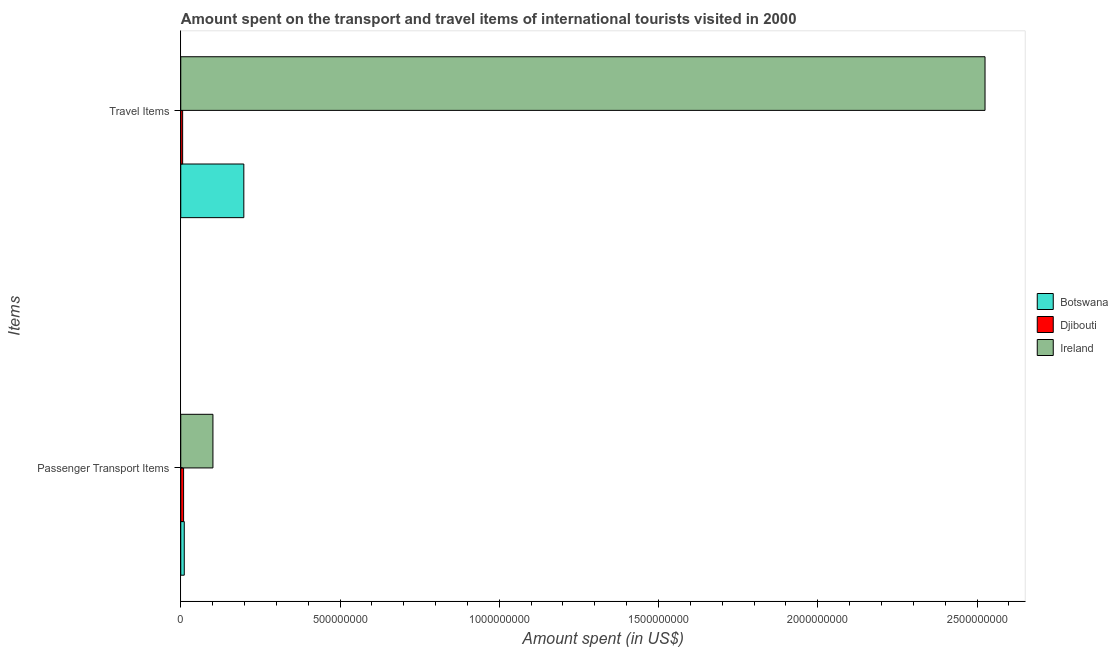How many different coloured bars are there?
Provide a short and direct response. 3. How many groups of bars are there?
Provide a short and direct response. 2. Are the number of bars per tick equal to the number of legend labels?
Your answer should be compact. Yes. Are the number of bars on each tick of the Y-axis equal?
Offer a terse response. Yes. What is the label of the 2nd group of bars from the top?
Your answer should be compact. Passenger Transport Items. What is the amount spent on passenger transport items in Botswana?
Give a very brief answer. 1.10e+07. Across all countries, what is the maximum amount spent in travel items?
Your answer should be very brief. 2.52e+09. Across all countries, what is the minimum amount spent on passenger transport items?
Offer a very short reply. 8.90e+06. In which country was the amount spent on passenger transport items maximum?
Keep it short and to the point. Ireland. In which country was the amount spent on passenger transport items minimum?
Your answer should be very brief. Djibouti. What is the total amount spent on passenger transport items in the graph?
Ensure brevity in your answer.  1.21e+08. What is the difference between the amount spent on passenger transport items in Ireland and that in Djibouti?
Ensure brevity in your answer.  9.21e+07. What is the difference between the amount spent in travel items in Djibouti and the amount spent on passenger transport items in Botswana?
Make the answer very short. -5.10e+06. What is the average amount spent in travel items per country?
Keep it short and to the point. 9.10e+08. What is the difference between the amount spent in travel items and amount spent on passenger transport items in Botswana?
Ensure brevity in your answer.  1.87e+08. What is the ratio of the amount spent in travel items in Djibouti to that in Botswana?
Your answer should be very brief. 0.03. What does the 2nd bar from the top in Passenger Transport Items represents?
Keep it short and to the point. Djibouti. What does the 2nd bar from the bottom in Passenger Transport Items represents?
Keep it short and to the point. Djibouti. Does the graph contain any zero values?
Ensure brevity in your answer.  No. How many legend labels are there?
Give a very brief answer. 3. How are the legend labels stacked?
Your response must be concise. Vertical. What is the title of the graph?
Your answer should be very brief. Amount spent on the transport and travel items of international tourists visited in 2000. What is the label or title of the X-axis?
Provide a short and direct response. Amount spent (in US$). What is the label or title of the Y-axis?
Provide a succinct answer. Items. What is the Amount spent (in US$) of Botswana in Passenger Transport Items?
Make the answer very short. 1.10e+07. What is the Amount spent (in US$) of Djibouti in Passenger Transport Items?
Give a very brief answer. 8.90e+06. What is the Amount spent (in US$) of Ireland in Passenger Transport Items?
Offer a terse response. 1.01e+08. What is the Amount spent (in US$) in Botswana in Travel Items?
Your answer should be compact. 1.98e+08. What is the Amount spent (in US$) in Djibouti in Travel Items?
Your response must be concise. 5.90e+06. What is the Amount spent (in US$) in Ireland in Travel Items?
Offer a terse response. 2.52e+09. Across all Items, what is the maximum Amount spent (in US$) in Botswana?
Ensure brevity in your answer.  1.98e+08. Across all Items, what is the maximum Amount spent (in US$) in Djibouti?
Make the answer very short. 8.90e+06. Across all Items, what is the maximum Amount spent (in US$) in Ireland?
Keep it short and to the point. 2.52e+09. Across all Items, what is the minimum Amount spent (in US$) in Botswana?
Offer a terse response. 1.10e+07. Across all Items, what is the minimum Amount spent (in US$) in Djibouti?
Provide a short and direct response. 5.90e+06. Across all Items, what is the minimum Amount spent (in US$) in Ireland?
Offer a terse response. 1.01e+08. What is the total Amount spent (in US$) in Botswana in the graph?
Ensure brevity in your answer.  2.09e+08. What is the total Amount spent (in US$) in Djibouti in the graph?
Offer a terse response. 1.48e+07. What is the total Amount spent (in US$) in Ireland in the graph?
Your answer should be very brief. 2.63e+09. What is the difference between the Amount spent (in US$) in Botswana in Passenger Transport Items and that in Travel Items?
Offer a very short reply. -1.87e+08. What is the difference between the Amount spent (in US$) of Djibouti in Passenger Transport Items and that in Travel Items?
Offer a terse response. 3.00e+06. What is the difference between the Amount spent (in US$) in Ireland in Passenger Transport Items and that in Travel Items?
Offer a very short reply. -2.42e+09. What is the difference between the Amount spent (in US$) of Botswana in Passenger Transport Items and the Amount spent (in US$) of Djibouti in Travel Items?
Ensure brevity in your answer.  5.10e+06. What is the difference between the Amount spent (in US$) of Botswana in Passenger Transport Items and the Amount spent (in US$) of Ireland in Travel Items?
Ensure brevity in your answer.  -2.51e+09. What is the difference between the Amount spent (in US$) of Djibouti in Passenger Transport Items and the Amount spent (in US$) of Ireland in Travel Items?
Provide a short and direct response. -2.52e+09. What is the average Amount spent (in US$) of Botswana per Items?
Give a very brief answer. 1.04e+08. What is the average Amount spent (in US$) in Djibouti per Items?
Your response must be concise. 7.40e+06. What is the average Amount spent (in US$) of Ireland per Items?
Make the answer very short. 1.31e+09. What is the difference between the Amount spent (in US$) of Botswana and Amount spent (in US$) of Djibouti in Passenger Transport Items?
Offer a terse response. 2.10e+06. What is the difference between the Amount spent (in US$) in Botswana and Amount spent (in US$) in Ireland in Passenger Transport Items?
Provide a succinct answer. -9.00e+07. What is the difference between the Amount spent (in US$) in Djibouti and Amount spent (in US$) in Ireland in Passenger Transport Items?
Offer a very short reply. -9.21e+07. What is the difference between the Amount spent (in US$) in Botswana and Amount spent (in US$) in Djibouti in Travel Items?
Keep it short and to the point. 1.92e+08. What is the difference between the Amount spent (in US$) of Botswana and Amount spent (in US$) of Ireland in Travel Items?
Provide a short and direct response. -2.33e+09. What is the difference between the Amount spent (in US$) in Djibouti and Amount spent (in US$) in Ireland in Travel Items?
Provide a succinct answer. -2.52e+09. What is the ratio of the Amount spent (in US$) of Botswana in Passenger Transport Items to that in Travel Items?
Offer a very short reply. 0.06. What is the ratio of the Amount spent (in US$) in Djibouti in Passenger Transport Items to that in Travel Items?
Your answer should be compact. 1.51. What is the difference between the highest and the second highest Amount spent (in US$) of Botswana?
Offer a very short reply. 1.87e+08. What is the difference between the highest and the second highest Amount spent (in US$) in Ireland?
Make the answer very short. 2.42e+09. What is the difference between the highest and the lowest Amount spent (in US$) in Botswana?
Offer a terse response. 1.87e+08. What is the difference between the highest and the lowest Amount spent (in US$) of Djibouti?
Your answer should be compact. 3.00e+06. What is the difference between the highest and the lowest Amount spent (in US$) of Ireland?
Provide a succinct answer. 2.42e+09. 